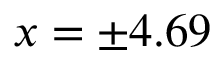<formula> <loc_0><loc_0><loc_500><loc_500>x = \pm 4 . 6 9</formula> 